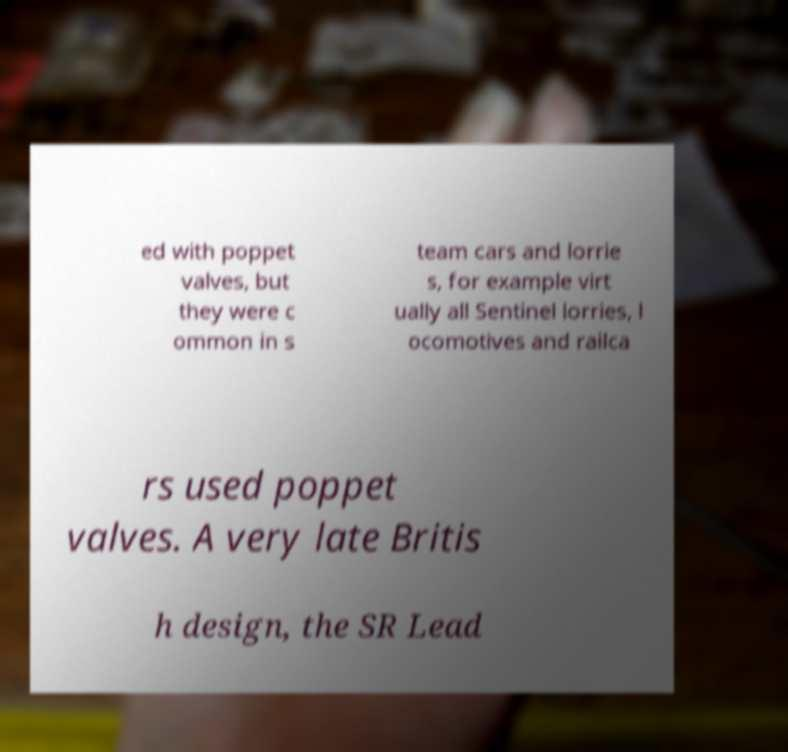Could you assist in decoding the text presented in this image and type it out clearly? ed with poppet valves, but they were c ommon in s team cars and lorrie s, for example virt ually all Sentinel lorries, l ocomotives and railca rs used poppet valves. A very late Britis h design, the SR Lead 